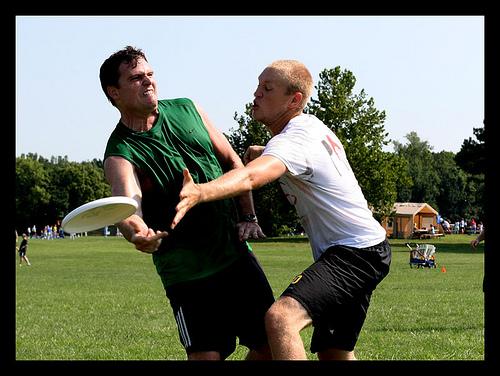The man on the right is wearing a color widely worn on what day?
Answer briefly. Wedding. Are they dancing?
Quick response, please. No. Are they fighting over the frisbee?
Give a very brief answer. Yes. 